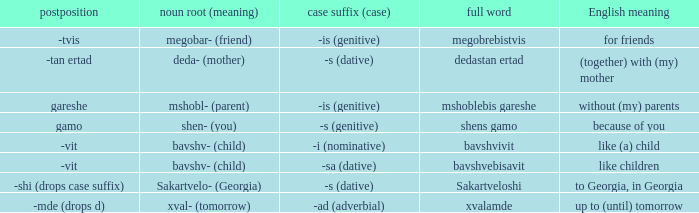What is English Meaning, when Case Suffix (Case) is "-sa (dative)"? Like children. 